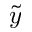Convert formula to latex. <formula><loc_0><loc_0><loc_500><loc_500>\tilde { y }</formula> 